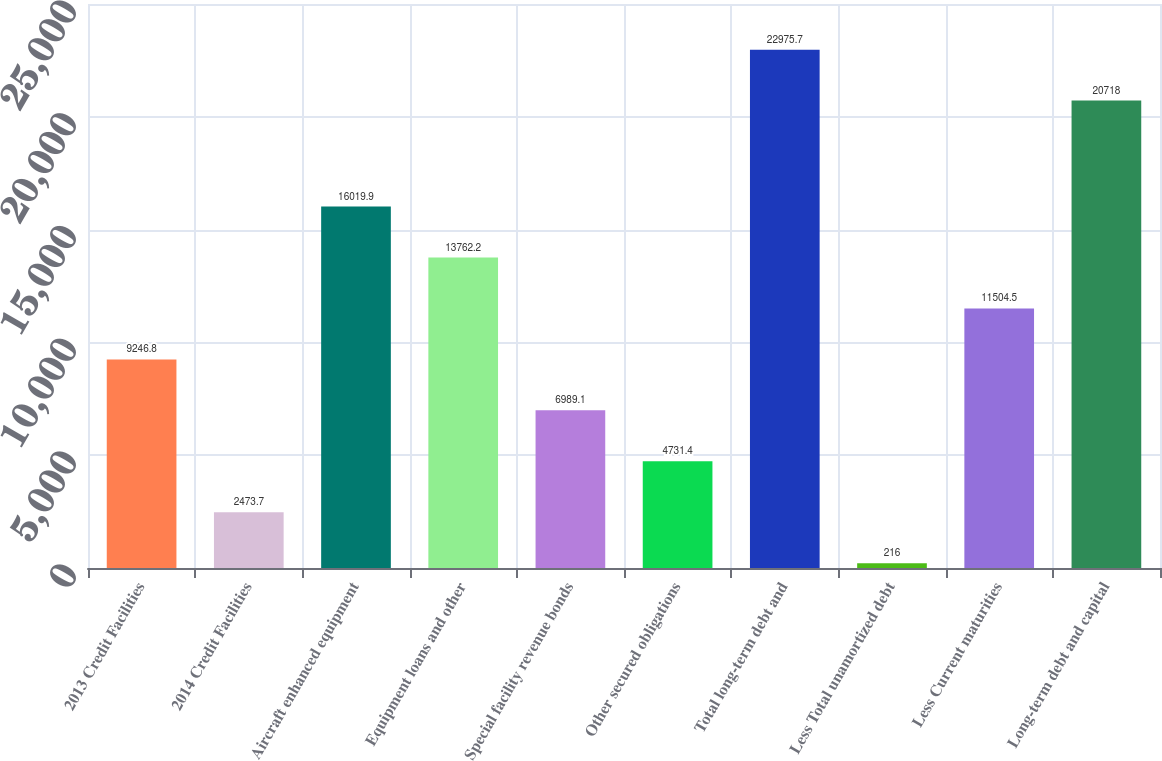<chart> <loc_0><loc_0><loc_500><loc_500><bar_chart><fcel>2013 Credit Facilities<fcel>2014 Credit Facilities<fcel>Aircraft enhanced equipment<fcel>Equipment loans and other<fcel>Special facility revenue bonds<fcel>Other secured obligations<fcel>Total long-term debt and<fcel>Less Total unamortized debt<fcel>Less Current maturities<fcel>Long-term debt and capital<nl><fcel>9246.8<fcel>2473.7<fcel>16019.9<fcel>13762.2<fcel>6989.1<fcel>4731.4<fcel>22975.7<fcel>216<fcel>11504.5<fcel>20718<nl></chart> 